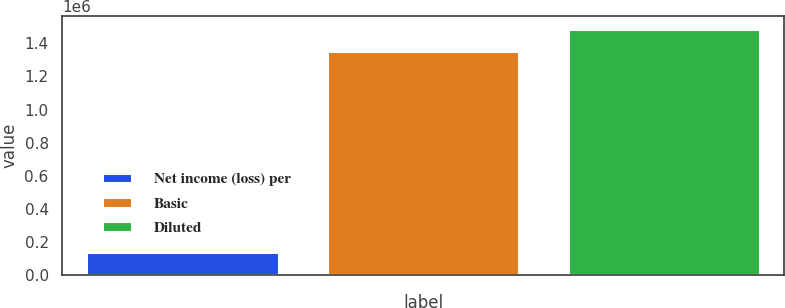<chart> <loc_0><loc_0><loc_500><loc_500><bar_chart><fcel>Net income (loss) per<fcel>Basic<fcel>Diluted<nl><fcel>136807<fcel>1.35208e+06<fcel>1.48888e+06<nl></chart> 